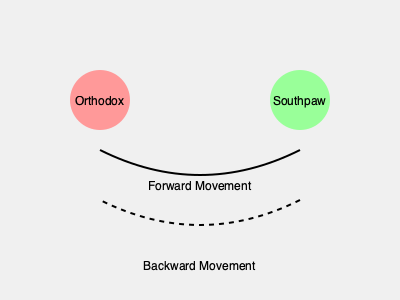In the diagram, which stance is typically associated with a right-handed boxer, and what does the solid curved line represent in terms of footwork? To answer this question, let's break it down step-by-step:

1. Stance identification:
   - The diagram shows two stances: Orthodox and Southpaw.
   - Orthodox stance is typically used by right-handed boxers.
   - Southpaw stance is typically used by left-handed boxers.

2. Footwork representation:
   - The diagram shows two curved lines: a solid line and a dashed line.
   - The solid line curves from left to right, moving from the Orthodox stance towards the Southpaw stance.
   - The dashed line curves from right to left, moving from the Southpaw stance towards the Orthodox stance.

3. Interpretation of the solid line:
   - The solid line is labeled "Forward Movement" in the diagram.
   - This indicates that the solid line represents the boxer moving forward in the ring.

Therefore, the Orthodox stance is typically associated with a right-handed boxer, and the solid curved line represents forward movement in terms of footwork.
Answer: Orthodox stance; forward movement 